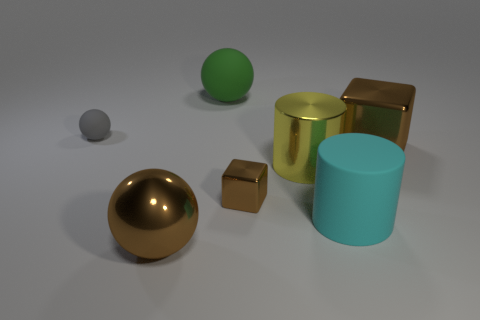How do the different textures on these objects affect the way light interacts with them? The textures on the objects play a significant role in light interaction. For instance, the polished gold surfaces reflect light smoothly and clearly because of their high luster, creating sharp and defined reflections, while the matte finishes scatter the light, reducing reflections and giving the objects a more diffused and soft appearance. 